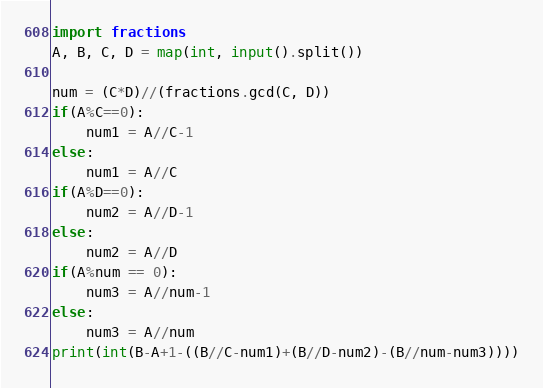<code> <loc_0><loc_0><loc_500><loc_500><_Python_>import fractions
A, B, C, D = map(int, input().split())

num = (C*D)//(fractions.gcd(C, D))
if(A%C==0):
    num1 = A//C-1
else:
    num1 = A//C
if(A%D==0):
    num2 = A//D-1
else:
    num2 = A//D
if(A%num == 0):
    num3 = A//num-1
else:
    num3 = A//num
print(int(B-A+1-((B//C-num1)+(B//D-num2)-(B//num-num3))))</code> 